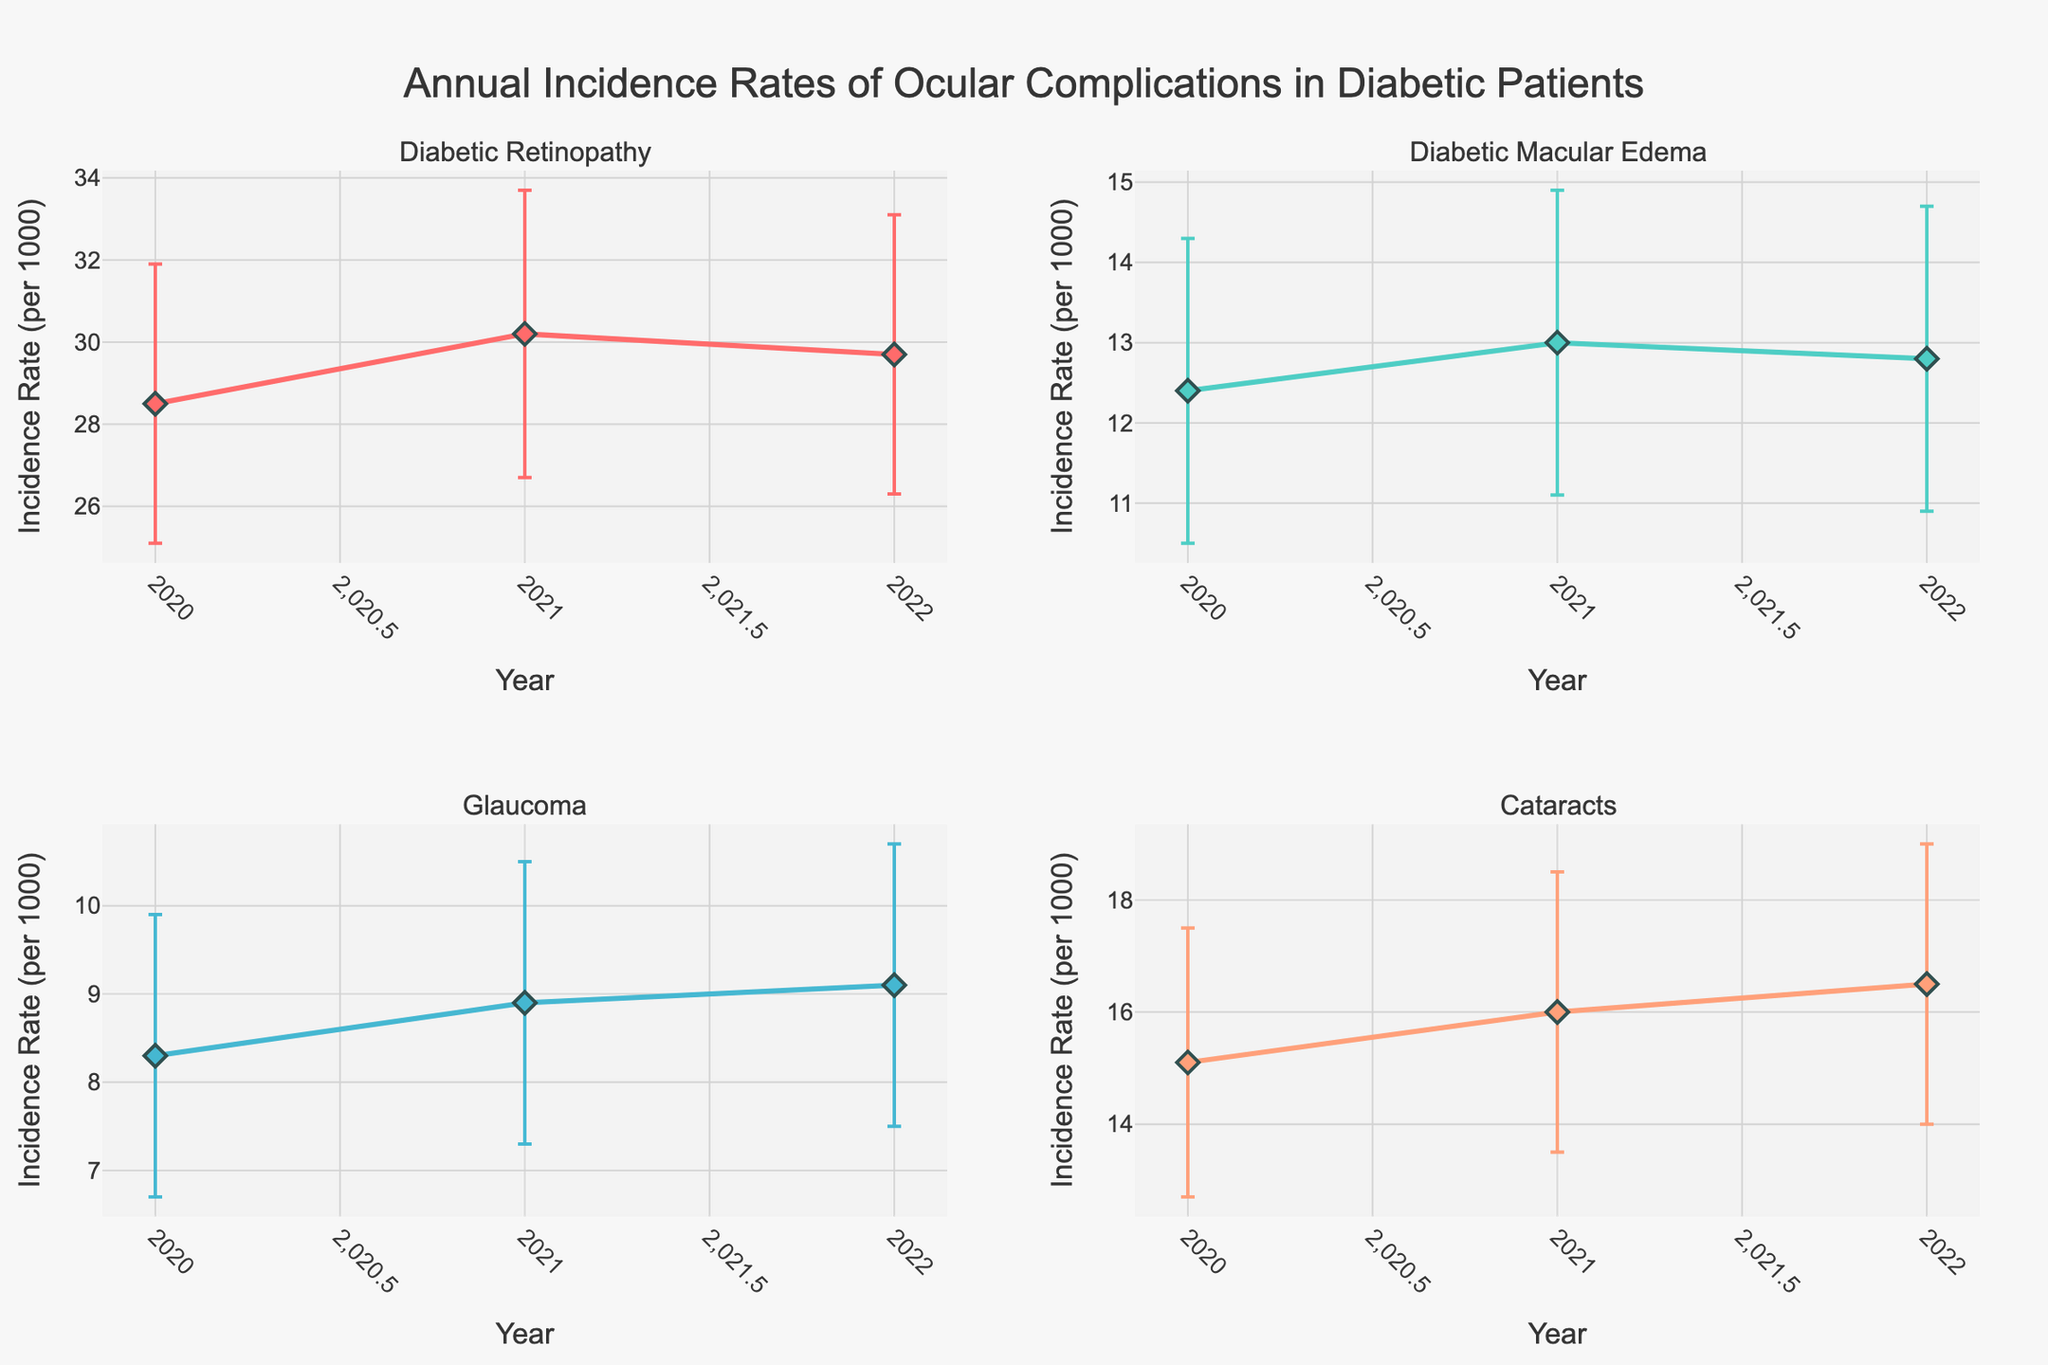what is the title of the figure? The title of the figure is displayed at the top center and reads "Annual Incidence Rates of Ocular Complications in Diabetic Patients".
Answer: Annual Incidence Rates of Ocular Complications in Diabetic Patients What are the ocular complications illustrated in the subplots? The subplot titles indicate the ocular complications, which are Diabetic Retinopathy, Diabetic Macular Edema, Glaucoma, and Cataracts.
Answer: Diabetic Retinopathy, Diabetic Macular Edema, Glaucoma, Cataracts What is the incidence rate of Diabetic Macular Edema in 2021? The incidence rate of Diabetic Macular Edema in 2021 is shown on the y-axis of the subplot for this complication and corresponds to the 2021 tick on the x-axis.
Answer: 13.0 per 1000 Which ocular complication had the highest incidence rate in 2022? By comparing the y-values for the year 2022, Diabetic Retinopathy has the highest incidence rate among the complications.
Answer: Diabetic Retinopathy How does the incidence rate of Glaucoma change from 2020 to 2022? The incidence rate of Glaucoma increased from 8.3 in 2020 to 8.9 in 2021 and further to 9.1 in 2022, as shown in the subplot for Glaucoma.
Answer: It increases What is the total range (difference between upper and lower bounds) of errors for Cataracts in 2020? The error bound for Cataracts in 2020 can be calculated by subtracting the lower bound from the upper bound (17.5 - 12.7).
Answer: 4.8 Which year shows the smallest error range for Diabetic Retinopathy? By comparing both the upper and lower bounds across the years for Diabetic Retinopathy, 2021 has the smallest error range (33.7 - 26.7).
Answer: 2021 How do the error bars for Glaucoma in 2022 compare to those in 2021? The error bars are visually represented by the range between the upper and lower bounds. In 2022, the error bars (7.5 to 10.7) are larger than in 2021 (7.3 to 10.5).
Answer: 2022 error bars are larger Did the incidence rate of Cataracts increase or decrease from 2020 to 2022? Observing the plot for Cataracts, the incidence rate increases from 15.1 in 2020 to 16.5 in 2022.
Answer: Increased Based on the plotted error bars, which complication has the highest variability in incidence rates in the year 2020? By comparing the length of the error bars for each complication in 2020, Diabetic Retinopathy shows the highest variability with the widest error bars.
Answer: Diabetic Retinopathy 